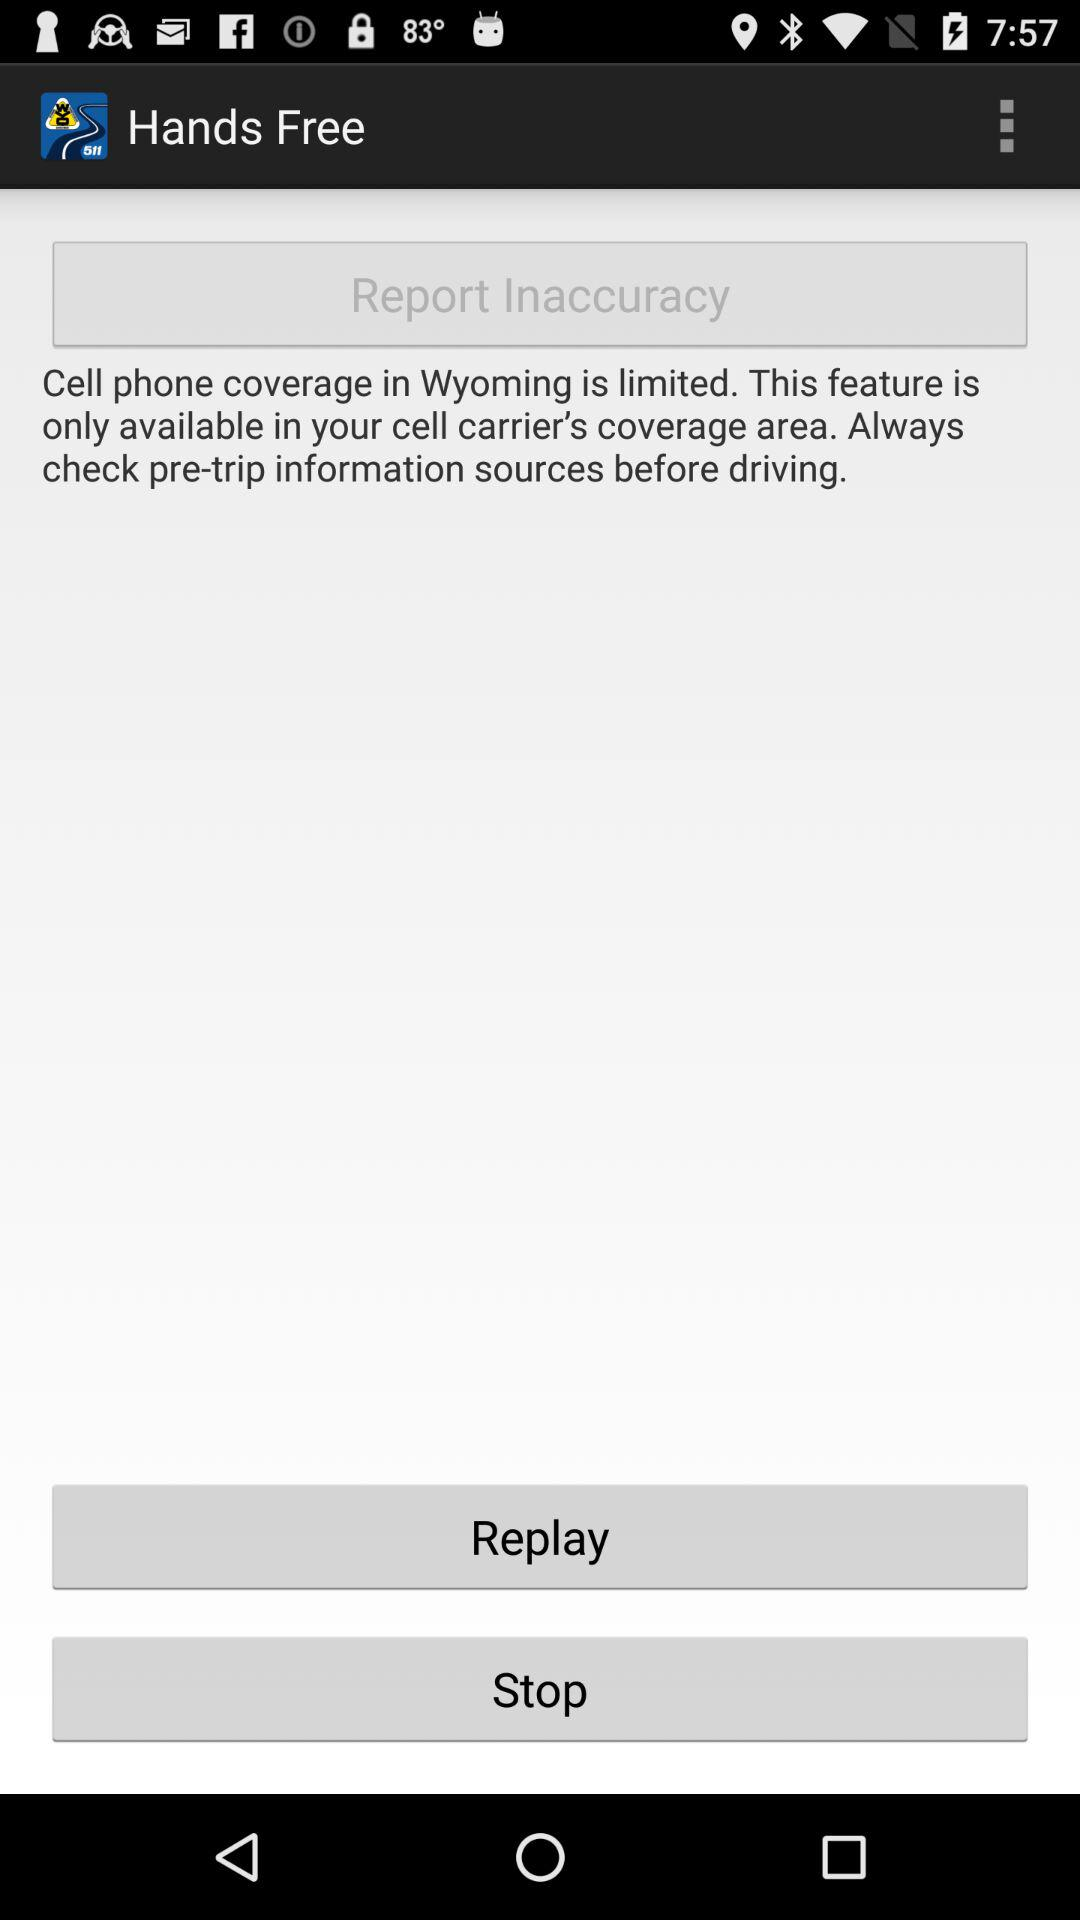What is the application name? The application name is "Wyoming". 